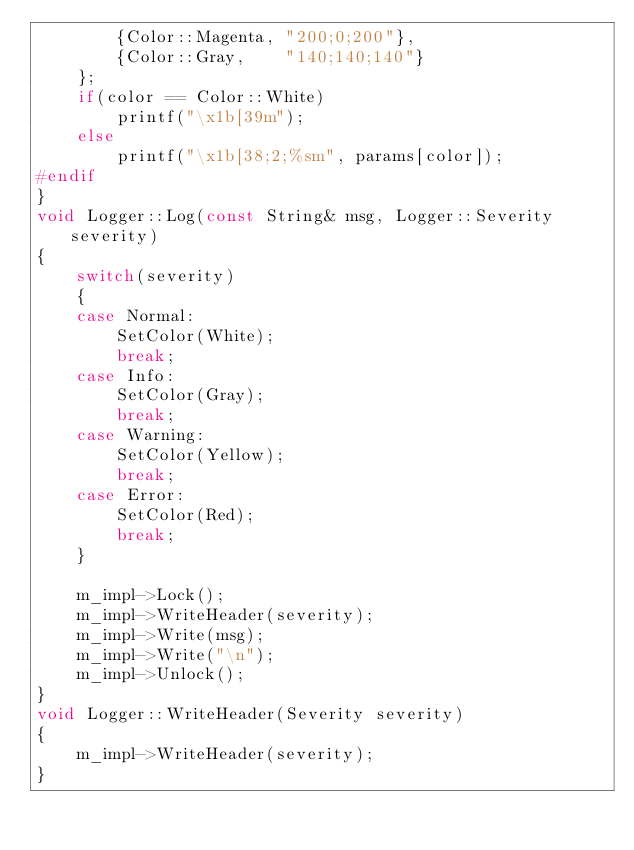<code> <loc_0><loc_0><loc_500><loc_500><_C++_>		{Color::Magenta, "200;0;200"},
		{Color::Gray,    "140;140;140"}
	};
	if(color == Color::White)
		printf("\x1b[39m");
	else
		printf("\x1b[38;2;%sm", params[color]);
#endif
}
void Logger::Log(const String& msg, Logger::Severity severity)
{
	switch(severity)
	{
	case Normal:
		SetColor(White);
		break;
	case Info:
		SetColor(Gray);
		break;
	case Warning:
		SetColor(Yellow);
		break;
	case Error:
		SetColor(Red);
		break;
	}

	m_impl->Lock();
	m_impl->WriteHeader(severity);
	m_impl->Write(msg);
	m_impl->Write("\n");
	m_impl->Unlock();
}
void Logger::WriteHeader(Severity severity)
{
	m_impl->WriteHeader(severity);
}</code> 